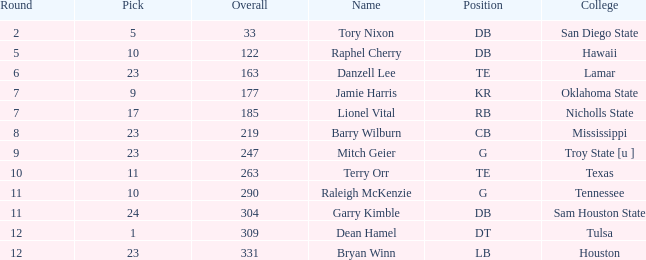How many selections are there from the college of hawaii with an overall rating below 122? 0.0. 